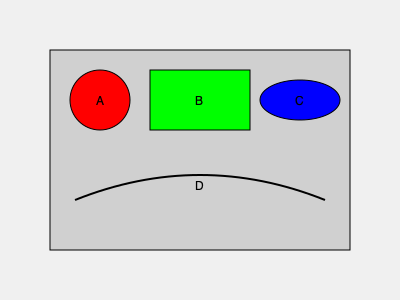In the diagram of a car engine above, which labeled part represents the alternator? To identify the alternator in this simplified engine diagram, let's go through each labeled part:

1. Part A (red circle): This shape and location typically represent the water pump in an engine diagram.

2. Part B (green rectangle): The rectangular shape in this position often represents the engine control unit (ECU) or fuse box.

3. Part C (blue ellipse): The elliptical shape at this location is characteristic of an alternator in most engine diagrams. The alternator is responsible for generating electrical power to charge the battery and run the car's electrical systems while the engine is running.

4. Part D (curved black line): This curved line likely represents a drive belt, which connects various engine components.

Based on this analysis, the part that most likely represents the alternator is Part C, the blue ellipse.
Answer: C 